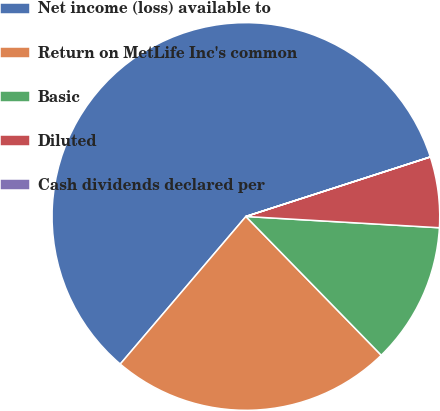Convert chart to OTSL. <chart><loc_0><loc_0><loc_500><loc_500><pie_chart><fcel>Net income (loss) available to<fcel>Return on MetLife Inc's common<fcel>Basic<fcel>Diluted<fcel>Cash dividends declared per<nl><fcel>58.8%<fcel>23.53%<fcel>11.77%<fcel>5.89%<fcel>0.01%<nl></chart> 